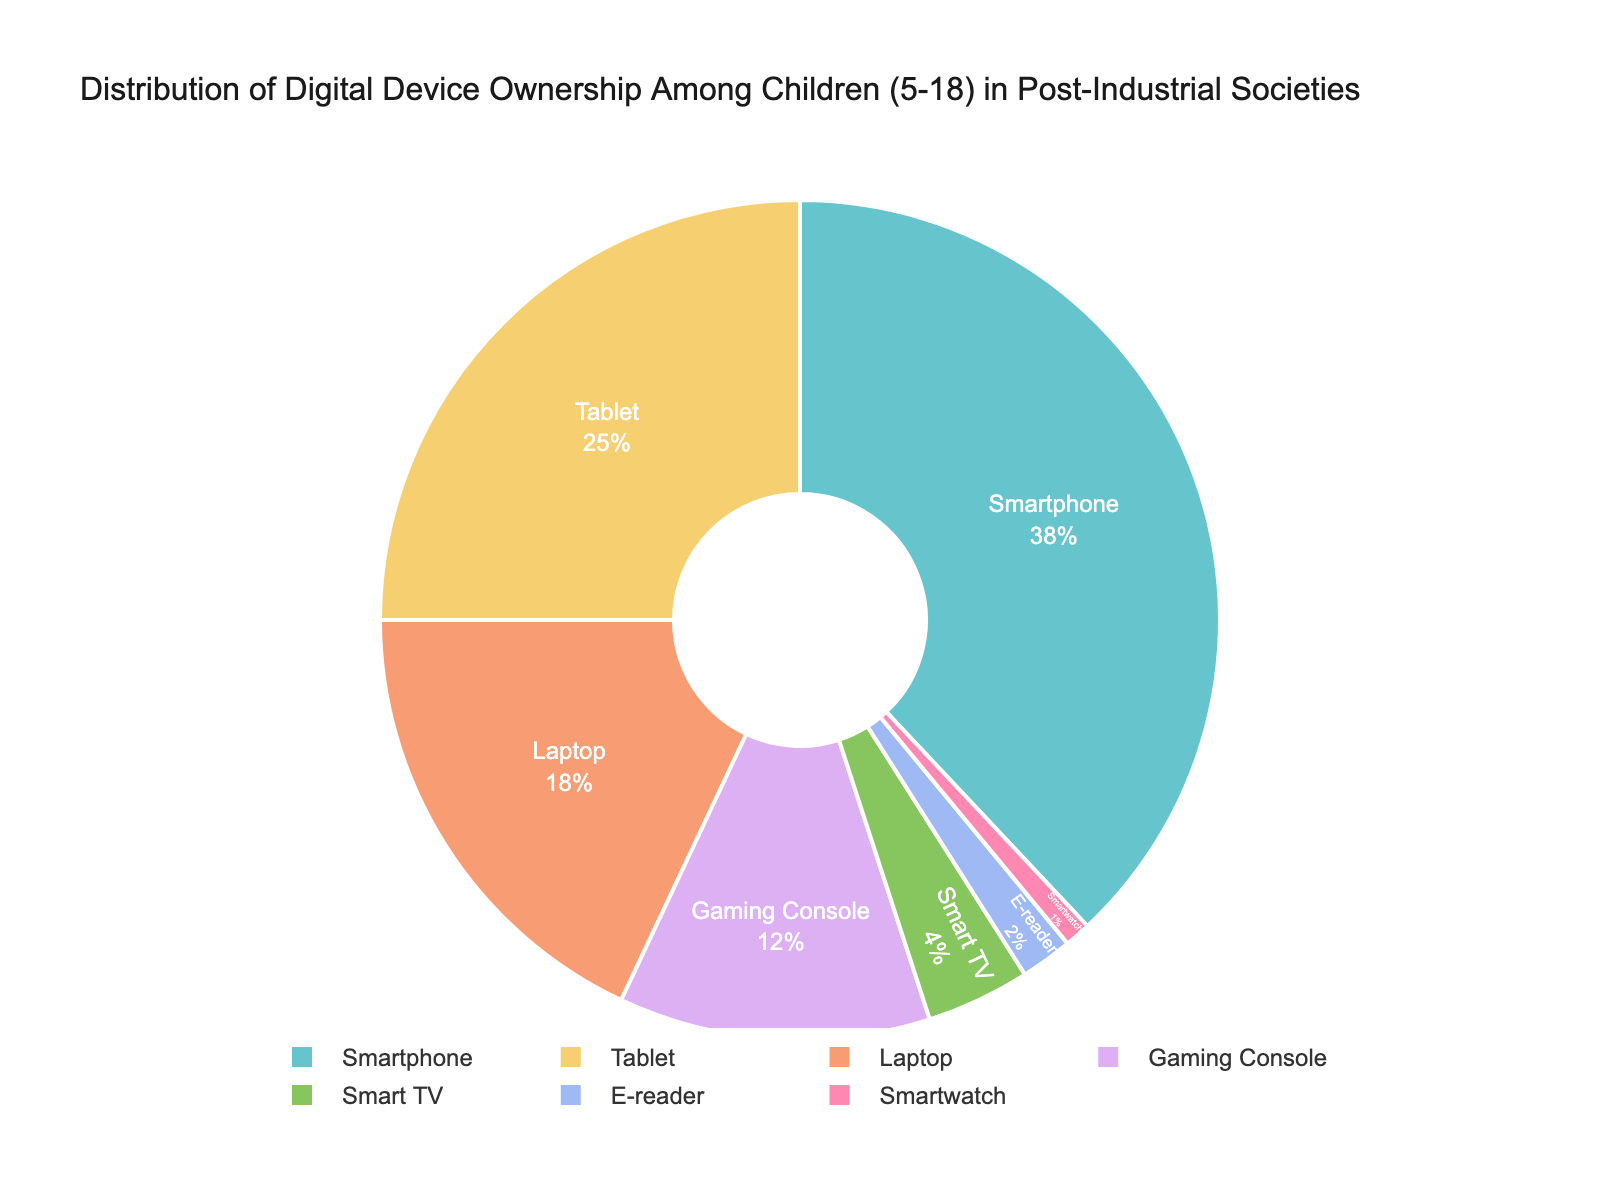what percentage of device ownership do laptops and tablets combine for? First, find the percentage for laptops, which is 18%. Then, find the percentage for tablets, which is 25%. Add these two values together: 18% + 25% = 43%
Answer: 43% which device type has the lowest ownership? The pie chart shows that the device with the lowest percentage is the smartwatch, with 1% ownership.
Answer: smartwatch how much higher is the ownership percentage of smartphones compared to gaming consoles? The ownership percentage for smartphones is 38% and for gaming consoles is 12%. Subtract the percentage of gaming consoles from smartphones: 38% - 12% = 26%
Answer: 26% what is the visual characteristic (like color) of the section representing smart TVs? The pie chart uses different colors for each device type. The section representing smart TVs is of a specific small area color in a pastel palette.
Answer: pastel color (specific color would be seen visually) are there more children owning e-readers or smartwatches? According to the chart, the percentage of ownership for e-readers is 2%, while for smartwatches it is 1%. Therefore, more children own e-readers.
Answer: e-readers compare the combined ownership of gaming consoles and smart TVs to laptops, which is higher? First, add the ownership percentages of gaming consoles (12%) and smart TVs (4%): 12% + 4% = 16%. Now compare this with the ownership of laptops (18%). Since 18% is greater than 16%, laptops have a higher ownership.
Answer: laptops is the percentage of children owning a tablet greater than those owning a smart TV and e-reader combined? The percentage of children owning a tablet is 25%. The combined percentage for smart TVs (4%) and e-readers (2%) is: 4% + 2% = 6%. Since 25% is greater than 6%, tablet ownership is greater.
Answer: yes 